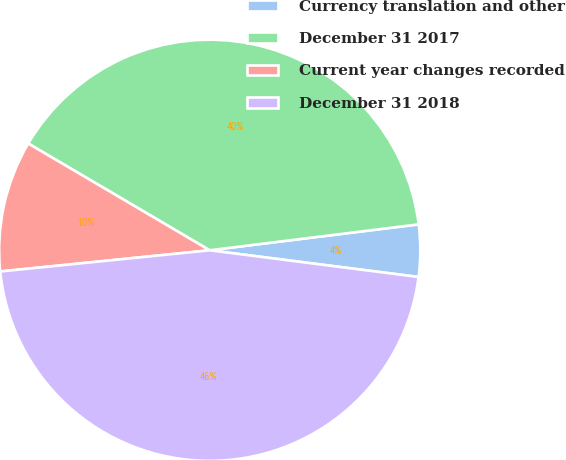Convert chart to OTSL. <chart><loc_0><loc_0><loc_500><loc_500><pie_chart><fcel>Currency translation and other<fcel>December 31 2017<fcel>Current year changes recorded<fcel>December 31 2018<nl><fcel>3.99%<fcel>39.57%<fcel>10.07%<fcel>46.37%<nl></chart> 